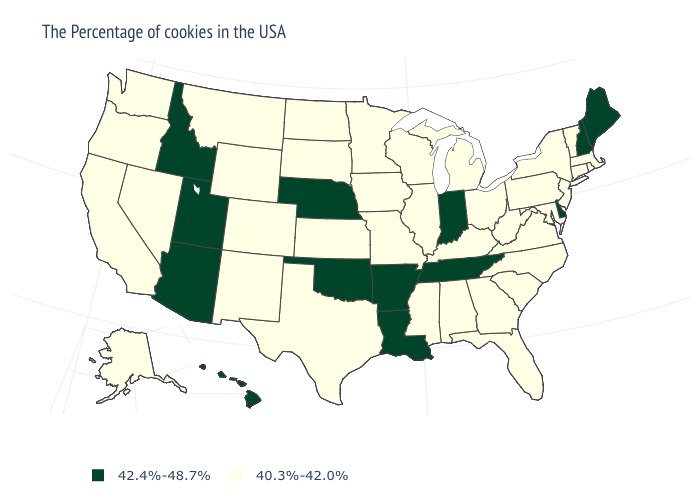What is the value of Utah?
Short answer required. 42.4%-48.7%. What is the value of Wyoming?
Keep it brief. 40.3%-42.0%. Name the states that have a value in the range 42.4%-48.7%?
Concise answer only. Maine, New Hampshire, Delaware, Indiana, Tennessee, Louisiana, Arkansas, Nebraska, Oklahoma, Utah, Arizona, Idaho, Hawaii. Which states have the lowest value in the USA?
Quick response, please. Massachusetts, Rhode Island, Vermont, Connecticut, New York, New Jersey, Maryland, Pennsylvania, Virginia, North Carolina, South Carolina, West Virginia, Ohio, Florida, Georgia, Michigan, Kentucky, Alabama, Wisconsin, Illinois, Mississippi, Missouri, Minnesota, Iowa, Kansas, Texas, South Dakota, North Dakota, Wyoming, Colorado, New Mexico, Montana, Nevada, California, Washington, Oregon, Alaska. What is the lowest value in states that border Massachusetts?
Give a very brief answer. 40.3%-42.0%. What is the value of Idaho?
Keep it brief. 42.4%-48.7%. Which states have the lowest value in the USA?
Short answer required. Massachusetts, Rhode Island, Vermont, Connecticut, New York, New Jersey, Maryland, Pennsylvania, Virginia, North Carolina, South Carolina, West Virginia, Ohio, Florida, Georgia, Michigan, Kentucky, Alabama, Wisconsin, Illinois, Mississippi, Missouri, Minnesota, Iowa, Kansas, Texas, South Dakota, North Dakota, Wyoming, Colorado, New Mexico, Montana, Nevada, California, Washington, Oregon, Alaska. Which states have the highest value in the USA?
Short answer required. Maine, New Hampshire, Delaware, Indiana, Tennessee, Louisiana, Arkansas, Nebraska, Oklahoma, Utah, Arizona, Idaho, Hawaii. Name the states that have a value in the range 40.3%-42.0%?
Quick response, please. Massachusetts, Rhode Island, Vermont, Connecticut, New York, New Jersey, Maryland, Pennsylvania, Virginia, North Carolina, South Carolina, West Virginia, Ohio, Florida, Georgia, Michigan, Kentucky, Alabama, Wisconsin, Illinois, Mississippi, Missouri, Minnesota, Iowa, Kansas, Texas, South Dakota, North Dakota, Wyoming, Colorado, New Mexico, Montana, Nevada, California, Washington, Oregon, Alaska. What is the value of Maryland?
Be succinct. 40.3%-42.0%. Name the states that have a value in the range 42.4%-48.7%?
Quick response, please. Maine, New Hampshire, Delaware, Indiana, Tennessee, Louisiana, Arkansas, Nebraska, Oklahoma, Utah, Arizona, Idaho, Hawaii. Does Arizona have the lowest value in the USA?
Be succinct. No. What is the lowest value in states that border Massachusetts?
Give a very brief answer. 40.3%-42.0%. What is the value of Mississippi?
Quick response, please. 40.3%-42.0%. Does Massachusetts have the highest value in the Northeast?
Short answer required. No. 